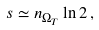Convert formula to latex. <formula><loc_0><loc_0><loc_500><loc_500>s \simeq n _ { \Omega _ { T } } \ln 2 \, ,</formula> 